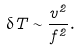Convert formula to latex. <formula><loc_0><loc_0><loc_500><loc_500>\delta T \sim \frac { v ^ { 2 } } { f ^ { 2 } } .</formula> 